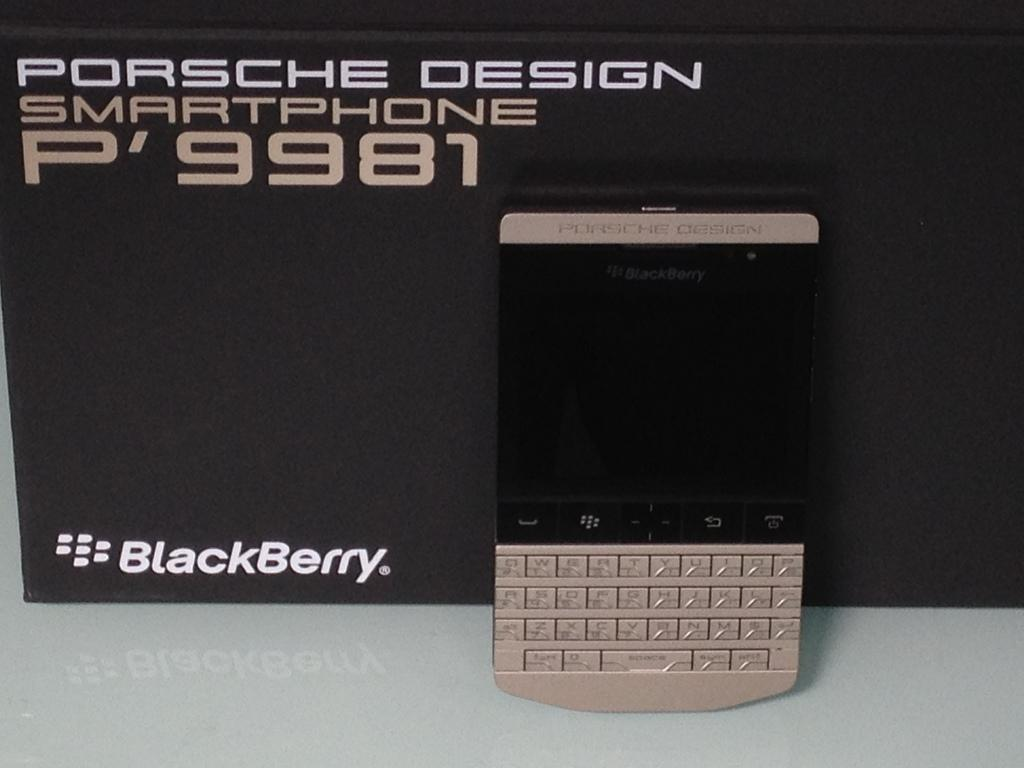<image>
Write a terse but informative summary of the picture. A Porsche Design BlackBerry P' 9981 smartphone stands in front of its box. 